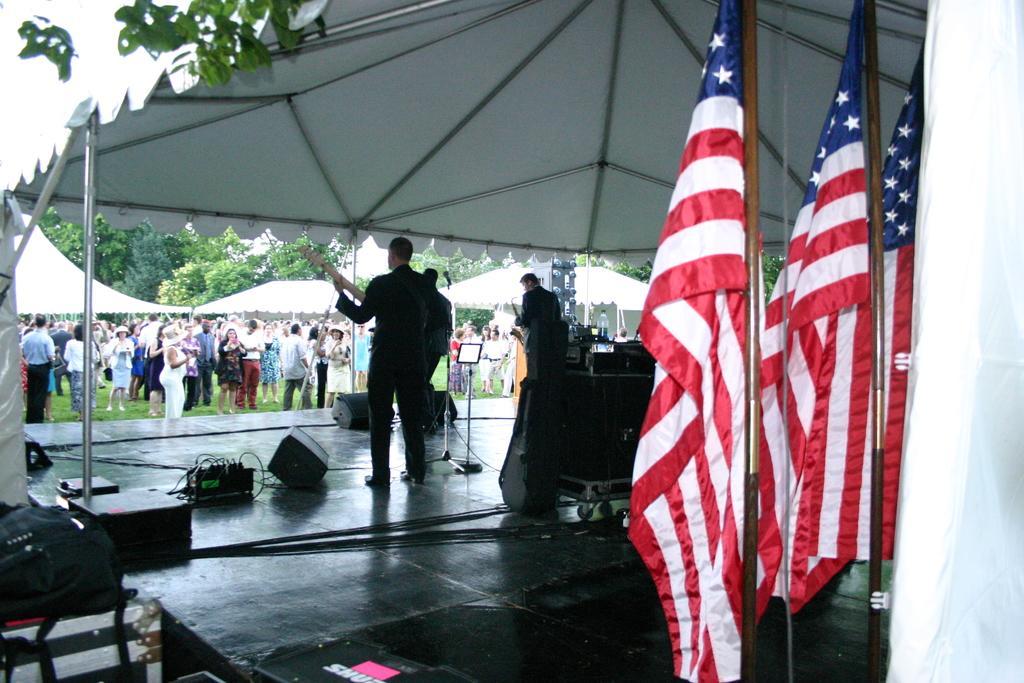How would you summarize this image in a sentence or two? In this image I can see few people standing and holding musical instruments. Back I can see few people standing and wearing different color dresses. I can see few white tents,trees,flags,speakers and few objects on the stage. 